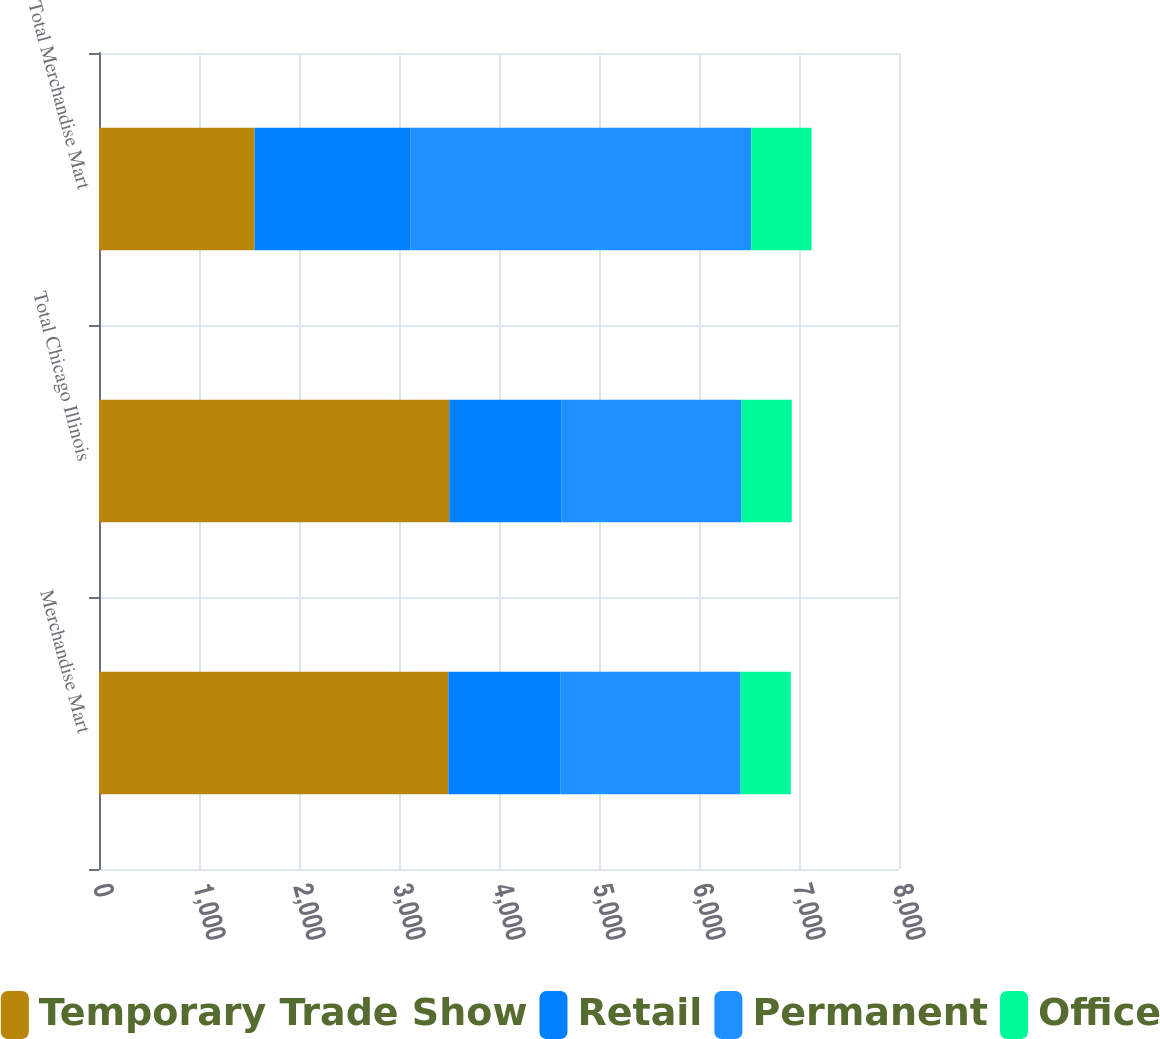Convert chart. <chart><loc_0><loc_0><loc_500><loc_500><stacked_bar_chart><ecel><fcel>Merchandise Mart<fcel>Total Chicago Illinois<fcel>Total Merchandise Mart<nl><fcel>Temporary Trade Show<fcel>3493<fcel>3503<fcel>1556<nl><fcel>Retail<fcel>1119<fcel>1119<fcel>1556<nl><fcel>Permanent<fcel>1804<fcel>1804<fcel>3411<nl><fcel>Office<fcel>502<fcel>502<fcel>603<nl></chart> 